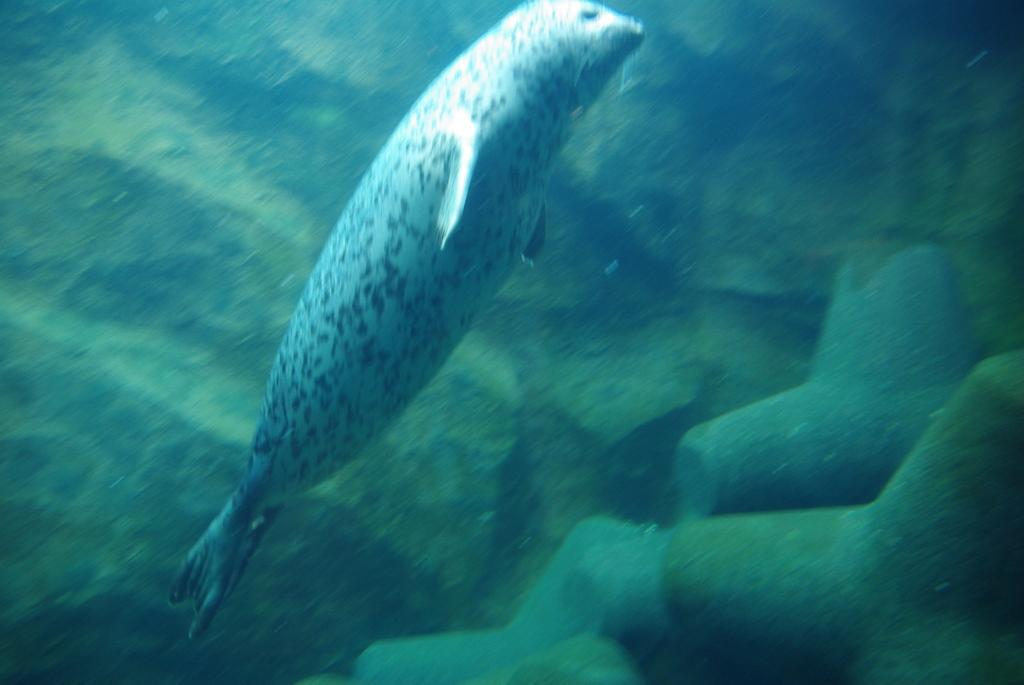What type of animal can be seen in the image? There is an ocean animal in the image. Where is the ocean animal located? The ocean animal is underwater. What type of underwear is the beetle wearing in the image? There is no beetle present in the image, and therefore no underwear can be observed. 